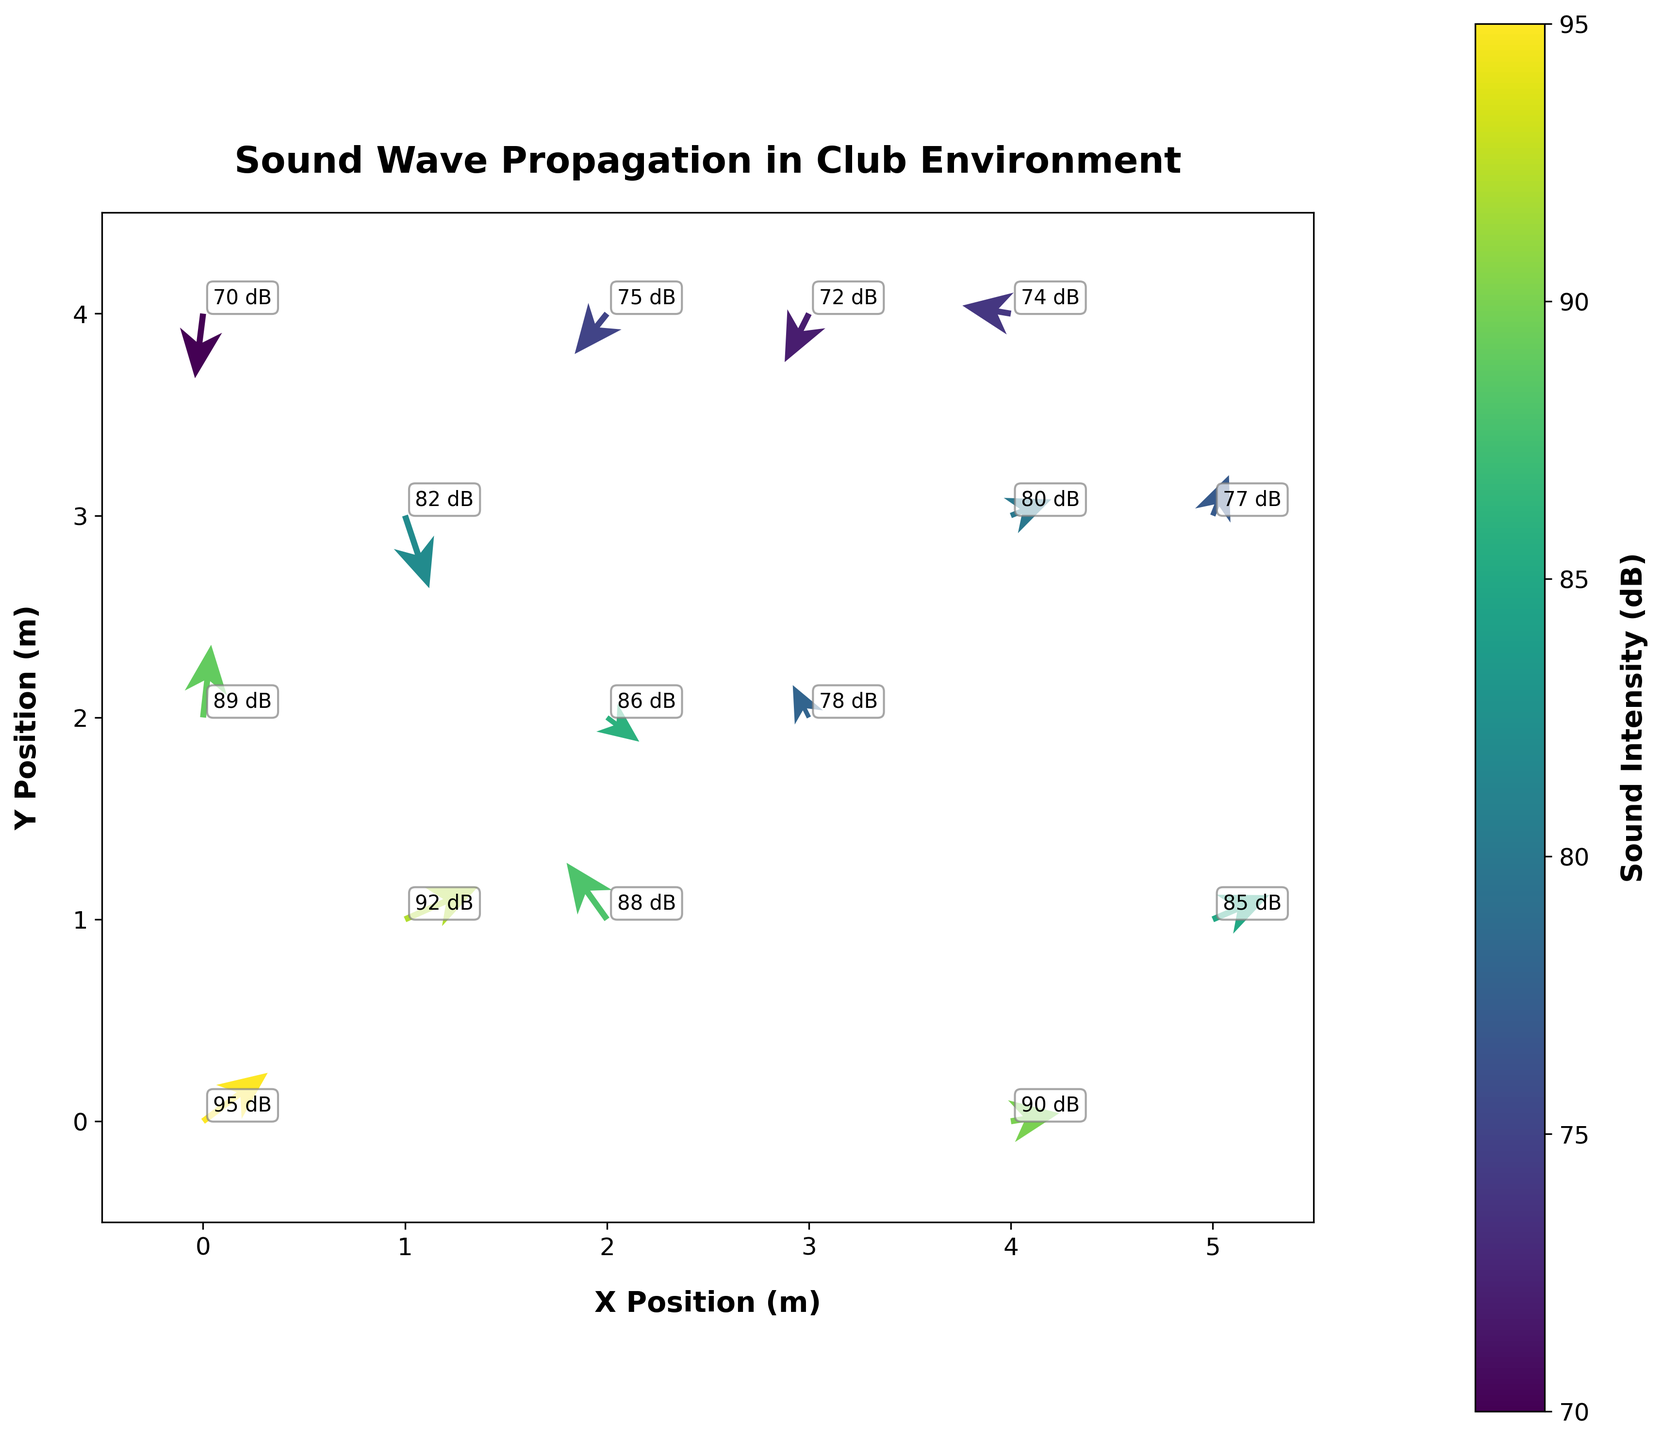What's the title of the chart? The title of the chart is displayed at the top of the figure in bold font.
Answer: Sound Wave Propagation in Club Environment How many data points are displayed in the figure? Count the number of origin points (arrows) in the figure.
Answer: 15 What does the color of the arrows represent? The color of the arrows corresponds to the sound intensity in decibels (dB), which is shown on the color bar to the right of the chart.
Answer: Sound Intensity (dB) Which data point has the highest sound intensity? Find the arrow annotated with the highest value in dB.
Answer: (0, 0) What's the average intensity of sound in the figure? Sum all the intensity values and divide by the number of data points: (95 + 88 + 82 + 78 + 90 + 75 + 85 + 70 + 80 + 92 + 72 + 77 + 86 + 74 + 89) / 15 = 80.87 dB
Answer: 80.87 dB Which data point has the largest arrow length? Calculate the vector lengths of the arrows using the Pythagorean theorem, then identify the longest: sqrt(0.8^2 + 0.6^2) = sqrt(1) = 1
Answer: (0, 0) Are there any data points where the sound wave is propagating directly downward? Check the vectors for those where the y-component (v) is negative and the x-component (u) is zero.
Answer: No At which positions is the sound intensity less than 80 dB? Identify and list the positions where the intensity values are below 80 (78, 75, 70, 72, 77, 74): (3, 2), (2, 4), (0, 4), (3, 4), (5, 3), (4, 4)
Answer: (3, 2), (2, 4), (0, 4), (3, 4), (5, 3), (4, 4) What are the directions of the sound waves at position (4, 0) and (2, 2)? Refer to the direction the arrows point at these positions: (4,0) points up and to the right, (2,2) points down and to the right
Answer: (4, 0) up-right, (2, 2) down-right Which data point has the smallest angle with the x-axis? Calculate the arctangent of the y-component over the x-component for each arrow and find the smallest angle: atan(0.3/0.9) = 18.43 degrees
Answer: (1, 1) 